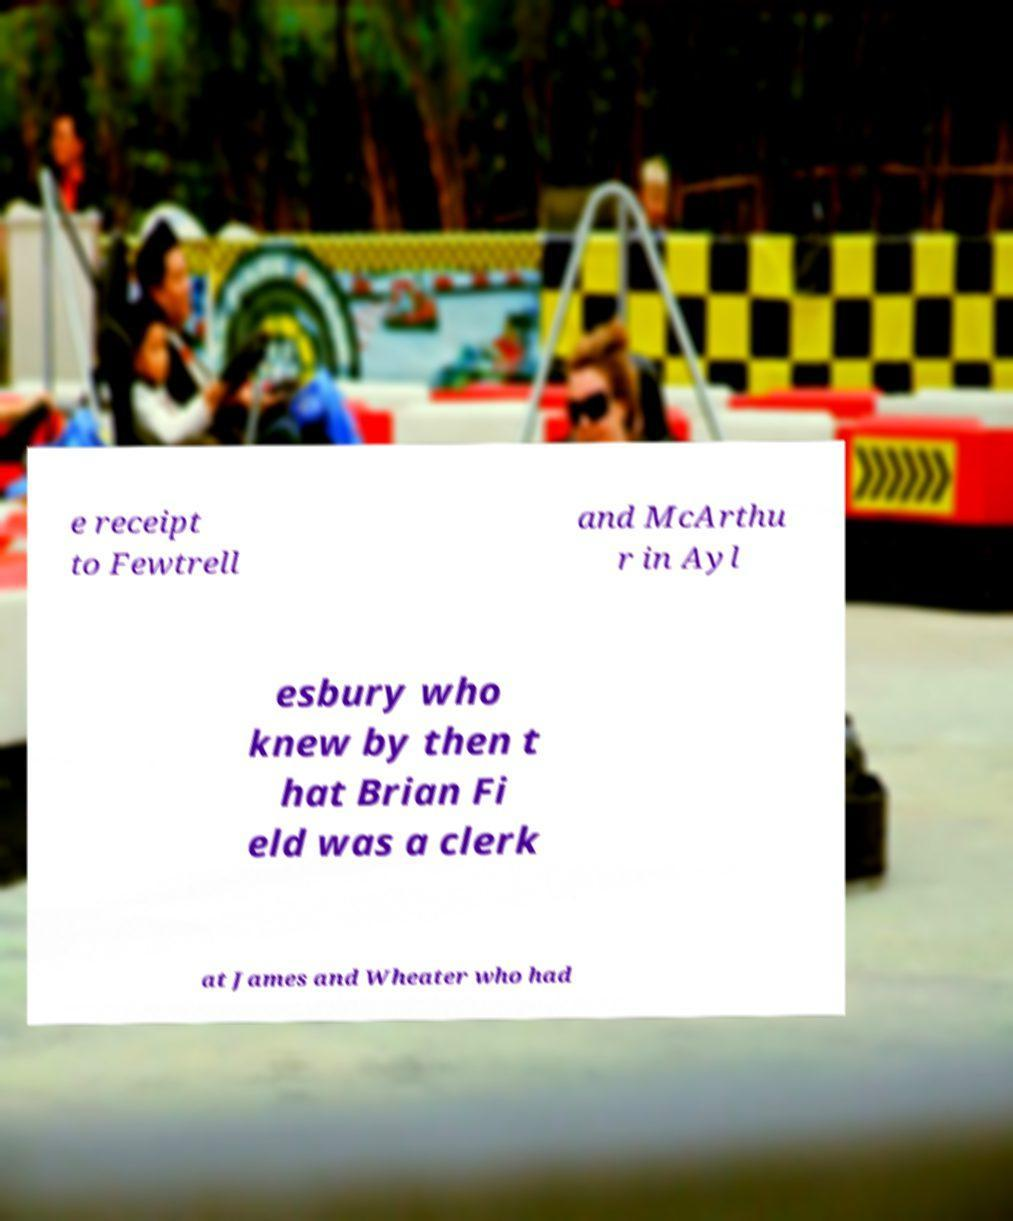Please read and relay the text visible in this image. What does it say? e receipt to Fewtrell and McArthu r in Ayl esbury who knew by then t hat Brian Fi eld was a clerk at James and Wheater who had 